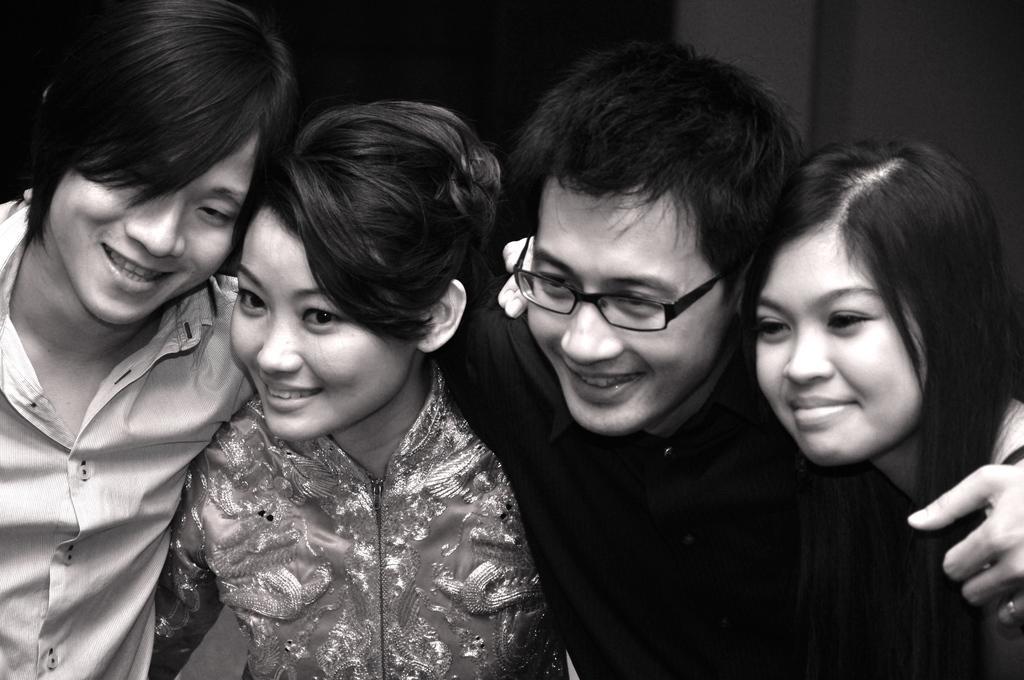Can you describe this image briefly? This is a black and white image. In this image we can see both men and women. 